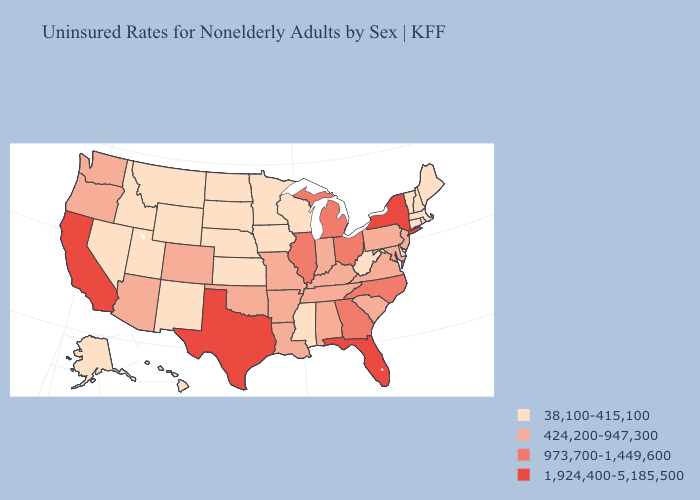Among the states that border Arizona , does Nevada have the highest value?
Quick response, please. No. What is the lowest value in the USA?
Be succinct. 38,100-415,100. Does Texas have the lowest value in the USA?
Short answer required. No. What is the lowest value in states that border Kansas?
Quick response, please. 38,100-415,100. What is the value of Nebraska?
Answer briefly. 38,100-415,100. Does Minnesota have the highest value in the MidWest?
Quick response, please. No. What is the value of Kentucky?
Concise answer only. 424,200-947,300. Among the states that border Florida , which have the highest value?
Concise answer only. Georgia. What is the highest value in states that border Nebraska?
Write a very short answer. 424,200-947,300. How many symbols are there in the legend?
Give a very brief answer. 4. What is the value of Indiana?
Be succinct. 424,200-947,300. What is the highest value in the USA?
Concise answer only. 1,924,400-5,185,500. What is the value of Massachusetts?
Keep it brief. 38,100-415,100. Name the states that have a value in the range 973,700-1,449,600?
Give a very brief answer. Georgia, Illinois, Michigan, North Carolina, Ohio. Does Massachusetts have the lowest value in the Northeast?
Quick response, please. Yes. 